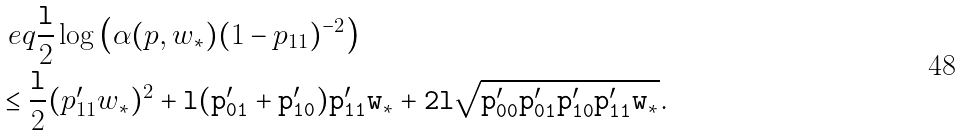Convert formula to latex. <formula><loc_0><loc_0><loc_500><loc_500>& \ e q \frac { \tt l } { 2 } \log \left ( \alpha ( p , w _ { * } ) ( 1 - p _ { 1 1 } ) ^ { - 2 } \right ) \\ & \leq \frac { \tt l } { 2 } ( p ^ { \prime } _ { 1 1 } w _ { * } ) ^ { 2 } + \tt l ( p ^ { \prime } _ { 0 1 } + p ^ { \prime } _ { 1 0 } ) p ^ { \prime } _ { 1 1 } w _ { * } + 2 \tt l \sqrt { p ^ { \prime } _ { 0 0 } p ^ { \prime } _ { 0 1 } p ^ { \prime } _ { 1 0 } p ^ { \prime } _ { 1 1 } w _ { * } } .</formula> 